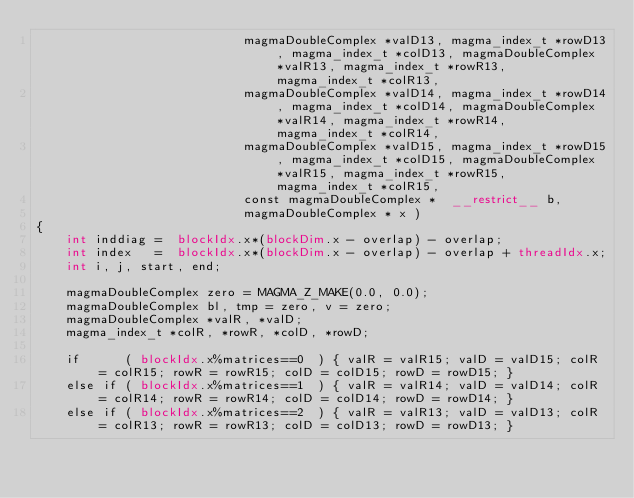Convert code to text. <code><loc_0><loc_0><loc_500><loc_500><_Cuda_>                            magmaDoubleComplex *valD13, magma_index_t *rowD13, magma_index_t *colD13, magmaDoubleComplex *valR13, magma_index_t *rowR13, magma_index_t *colR13, 
                            magmaDoubleComplex *valD14, magma_index_t *rowD14, magma_index_t *colD14, magmaDoubleComplex *valR14, magma_index_t *rowR14, magma_index_t *colR14, 
                            magmaDoubleComplex *valD15, magma_index_t *rowD15, magma_index_t *colD15, magmaDoubleComplex *valR15, magma_index_t *rowR15, magma_index_t *colR15,  
                            const magmaDoubleComplex *  __restrict__ b,                            
                            magmaDoubleComplex * x )
{
    int inddiag =  blockIdx.x*(blockDim.x - overlap) - overlap;
    int index   =  blockIdx.x*(blockDim.x - overlap) - overlap + threadIdx.x;
    int i, j, start, end;
    
    magmaDoubleComplex zero = MAGMA_Z_MAKE(0.0, 0.0);
    magmaDoubleComplex bl, tmp = zero, v = zero; 
    magmaDoubleComplex *valR, *valD;
    magma_index_t *colR, *rowR, *colD, *rowD;
    
    if      ( blockIdx.x%matrices==0  ) { valR = valR15; valD = valD15; colR = colR15; rowR = rowR15; colD = colD15; rowD = rowD15; }
    else if ( blockIdx.x%matrices==1  ) { valR = valR14; valD = valD14; colR = colR14; rowR = rowR14; colD = colD14; rowD = rowD14; }
    else if ( blockIdx.x%matrices==2  ) { valR = valR13; valD = valD13; colR = colR13; rowR = rowR13; colD = colD13; rowD = rowD13; }</code> 